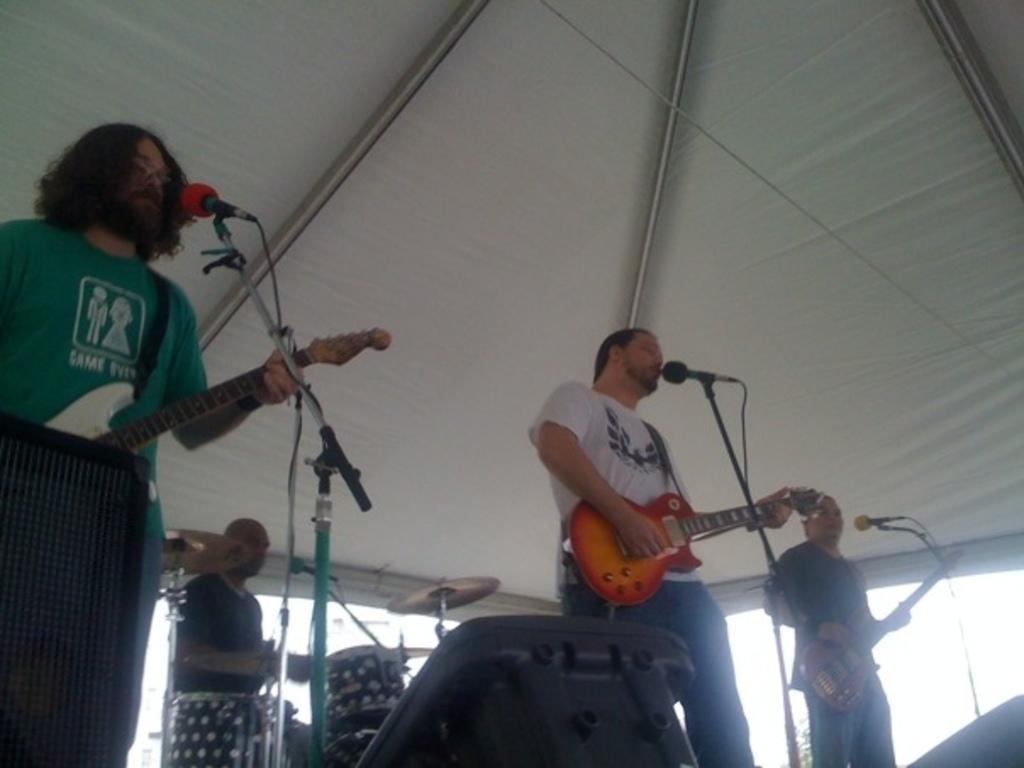How would you summarize this image in a sentence or two? There are four people. In that three people are playing guitar and singing song. In front of them there are mics and mic stand also. Behind them there is a person playing drums. 